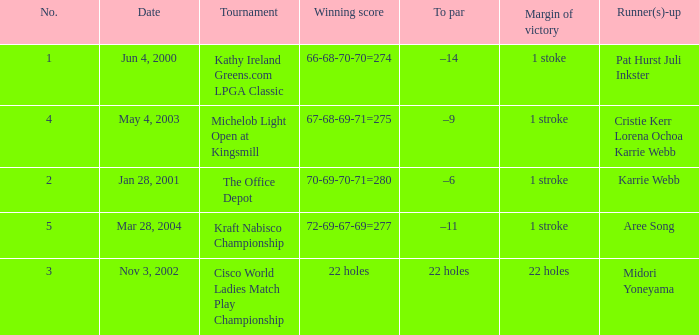What is the to par dated may 4, 2003? –9. 